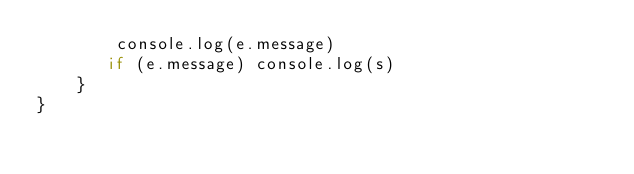<code> <loc_0><loc_0><loc_500><loc_500><_JavaScript_>        console.log(e.message)
       if (e.message) console.log(s)
    }
}</code> 